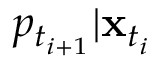<formula> <loc_0><loc_0><loc_500><loc_500>p _ { t _ { i + 1 } } | x _ { t _ { i } }</formula> 